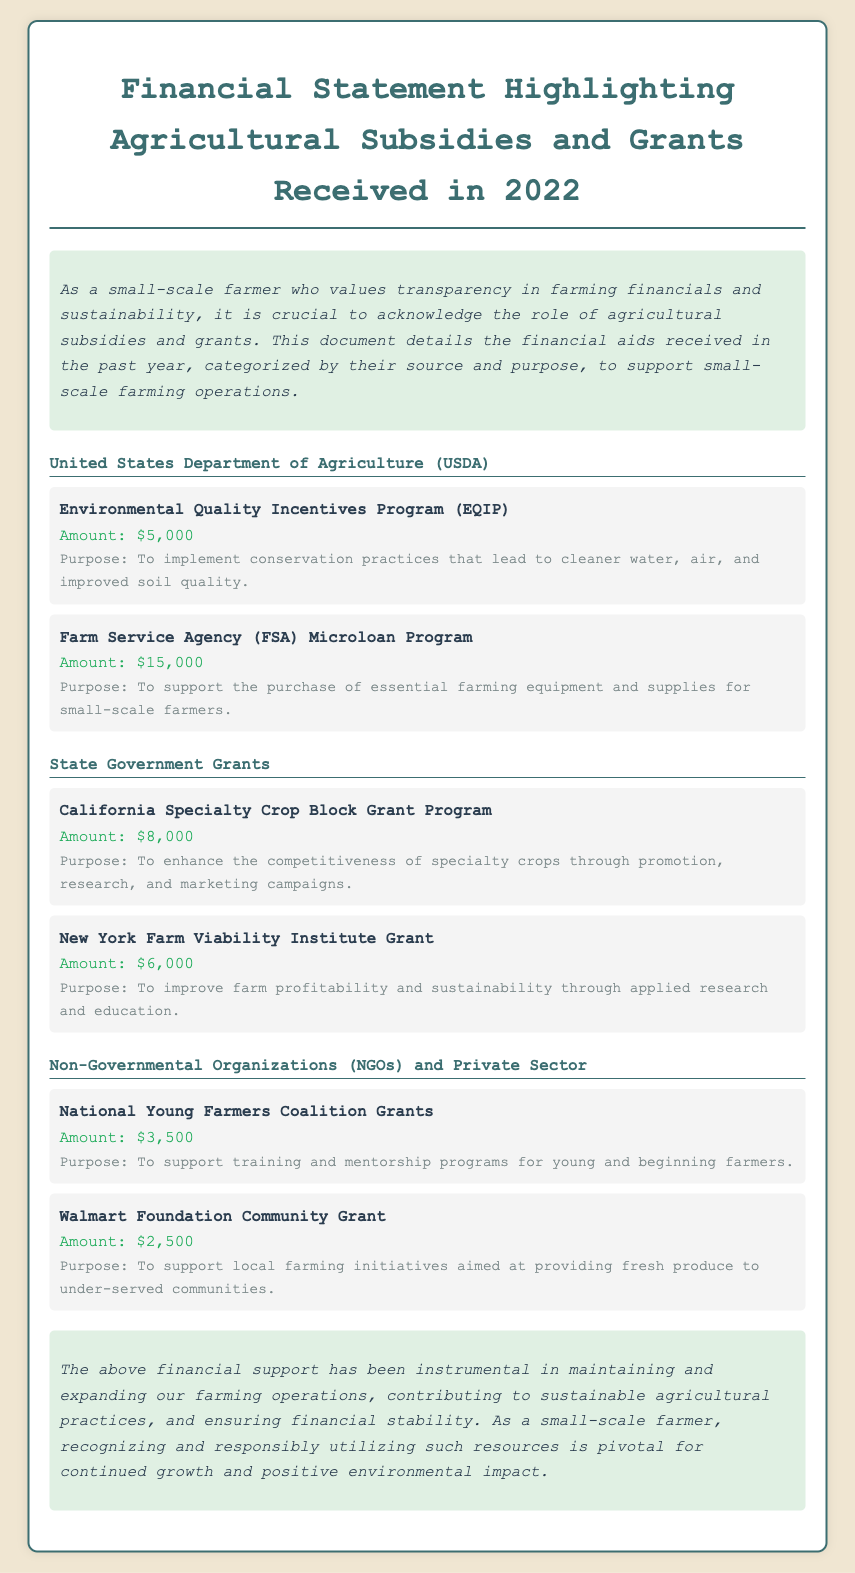What is the total amount received from the USDA? The total amount received from the USDA is the sum of the grants listed under that category, which is $5,000 + $15,000 = $20,000.
Answer: $20,000 What is the purpose of the Environmental Quality Incentives Program (EQIP)? The purpose of this program is detailed in the document and it is to implement conservation practices that lead to cleaner water, air, and improved soil quality.
Answer: To implement conservation practices How much was received from the California Specialty Crop Block Grant Program? The amount received from this grant is specified in the document as $8,000.
Answer: $8,000 What organization provided the National Young Farmers Coalition Grants? The organization that provided these grants is categorized as a Non-Governmental Organization (NGO).
Answer: NGO What is the total amount received from Non-Governmental Organizations and Private Sector? The total amount is calculated as the sum of all grants in this category, which is $3,500 + $2,500 = $6,000.
Answer: $6,000 What is the primary focus of the Walmart Foundation Community Grant? The primary focus of this grant is described as supporting local farming initiatives aimed at providing fresh produce to under-served communities.
Answer: Providing fresh produce How many grants were listed under State Government Grants? The number of grants in this category is straightforward as there are two listed grants in the document.
Answer: Two What is the total amount of financial support listed in the document? To find the total financial support, sum up all amounts from each category: $20,000 + $14,000 + $6,000.
Answer: $40,000 What year does the financial statement pertain to? The financial statement specifically mentions the year it covers, which is 2022.
Answer: 2022 